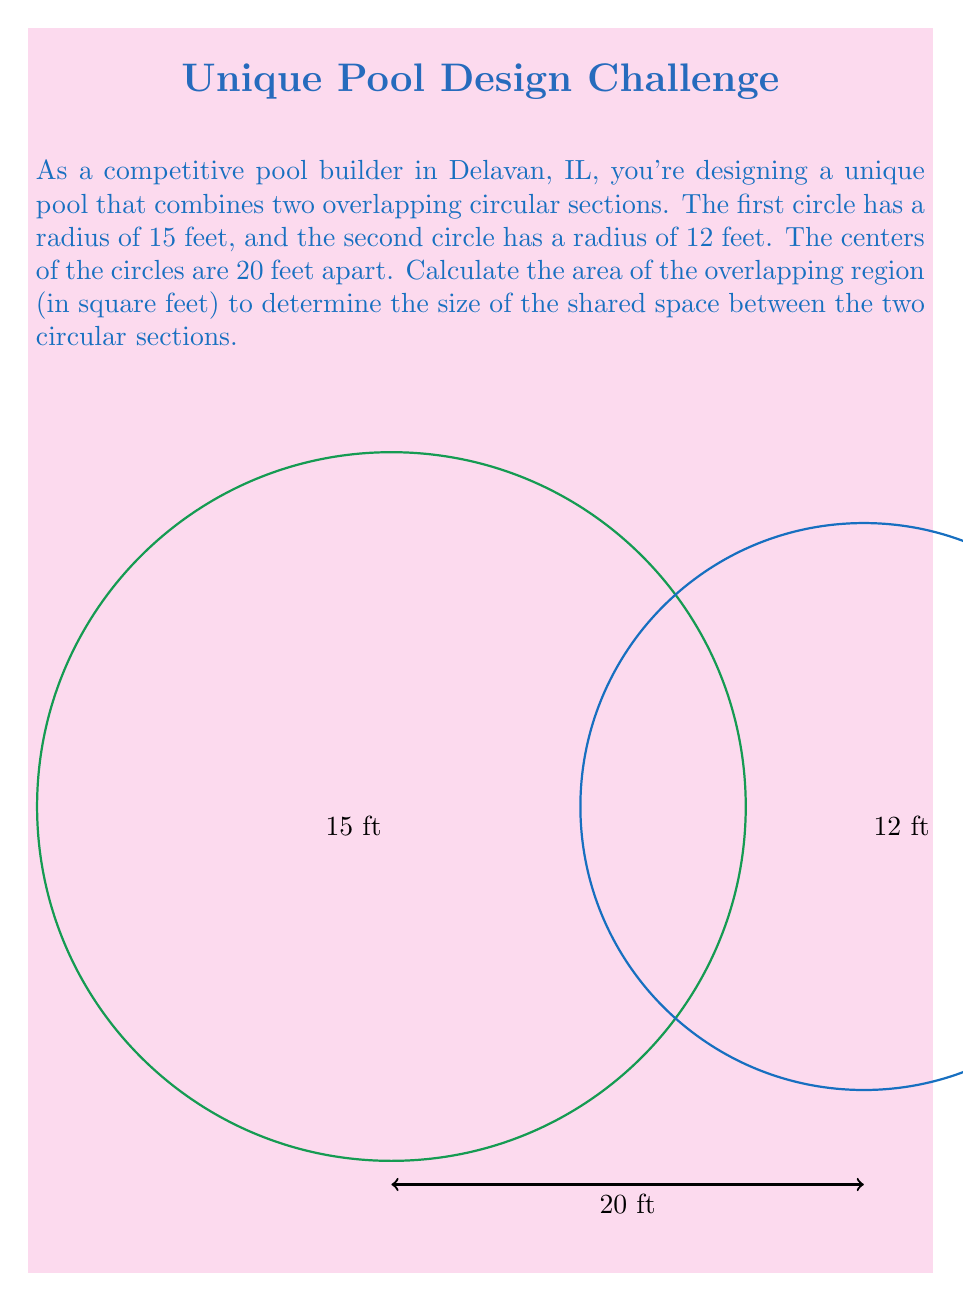What is the answer to this math problem? To solve this problem, we need to use the formula for the area of intersection between two circles. Let's break it down step-by-step:

1) First, we need to find the distance $d$ between the centers of the circles. We're given that $d = 20$ feet.

2) Let $R = 15$ (radius of the larger circle) and $r = 12$ (radius of the smaller circle).

3) The formula for the area of intersection is:

   $$A = R^2 \arccos(\frac{d^2 + R^2 - r^2}{2dR}) + r^2 \arccos(\frac{d^2 + r^2 - R^2}{2dr}) - \frac{1}{2}\sqrt{(-d+r+R)(d+r-R)(d-r+R)(d+r+R)}$$

4) Let's substitute our values:

   $$A = 15^2 \arccos(\frac{20^2 + 15^2 - 12^2}{2 \cdot 20 \cdot 15}) + 12^2 \arccos(\frac{20^2 + 12^2 - 15^2}{2 \cdot 20 \cdot 12}) - \frac{1}{2}\sqrt{(-20+12+15)(20+12-15)(20-12+15)(20+12+15)}$$

5) Simplify inside the arccos functions:

   $$A = 225 \arccos(\frac{400 + 225 - 144}{600}) + 144 \arccos(\frac{400 + 144 - 225}{480}) - \frac{1}{2}\sqrt{(7)(17)(23)(47)}$$

6) Simplify further:

   $$A = 225 \arccos(0.8017) + 144 \arccos(0.6646) - \frac{1}{2}\sqrt{134,827}$$

7) Calculate:

   $$A \approx 225 \cdot 0.6435 + 144 \cdot 0.8185 - \frac{1}{2} \cdot 367.19$$

   $$A \approx 144.7875 + 117.864 - 183.595$$

   $$A \approx 79.0565 \text{ square feet}$$

8) Rounding to two decimal places:

   $$A \approx 79.06 \text{ square feet}$$
Answer: $79.06 \text{ ft}^2$ 